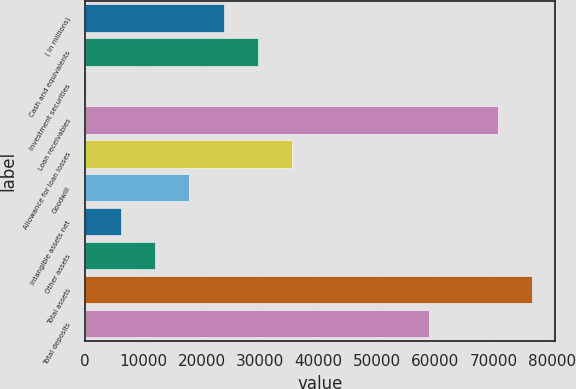Convert chart to OTSL. <chart><loc_0><loc_0><loc_500><loc_500><bar_chart><fcel>( in millions)<fcel>Cash and equivalents<fcel>Investment securities<fcel>Loan receivables<fcel>Allowance for loan losses<fcel>Goodwill<fcel>Intangible assets net<fcel>Other assets<fcel>Total assets<fcel>Total deposits<nl><fcel>23736.8<fcel>29612<fcel>236<fcel>70738.4<fcel>35487.2<fcel>17861.6<fcel>6111.2<fcel>11986.4<fcel>76613.6<fcel>58988<nl></chart> 